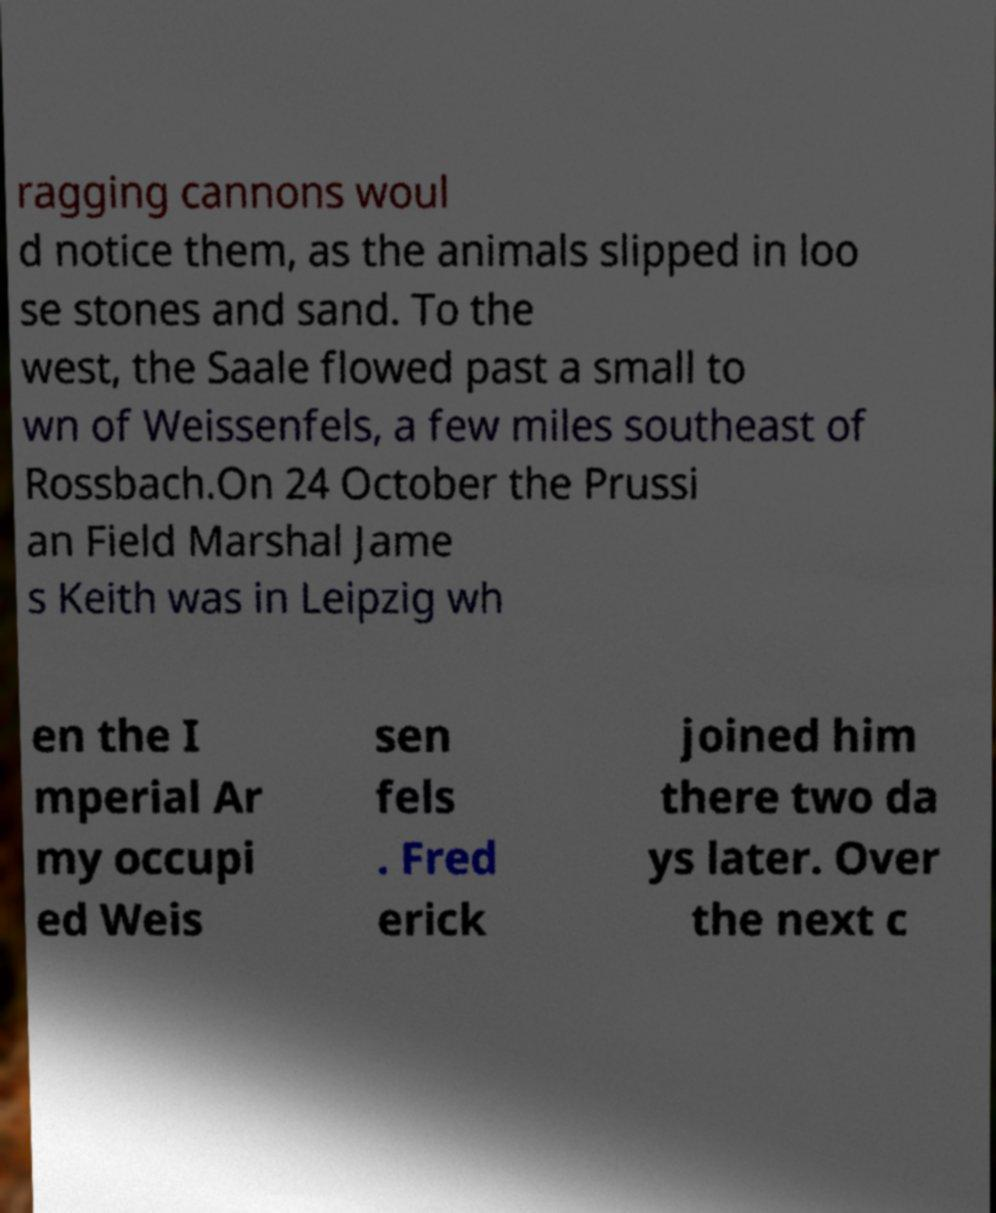Can you read and provide the text displayed in the image?This photo seems to have some interesting text. Can you extract and type it out for me? ragging cannons woul d notice them, as the animals slipped in loo se stones and sand. To the west, the Saale flowed past a small to wn of Weissenfels, a few miles southeast of Rossbach.On 24 October the Prussi an Field Marshal Jame s Keith was in Leipzig wh en the I mperial Ar my occupi ed Weis sen fels . Fred erick joined him there two da ys later. Over the next c 